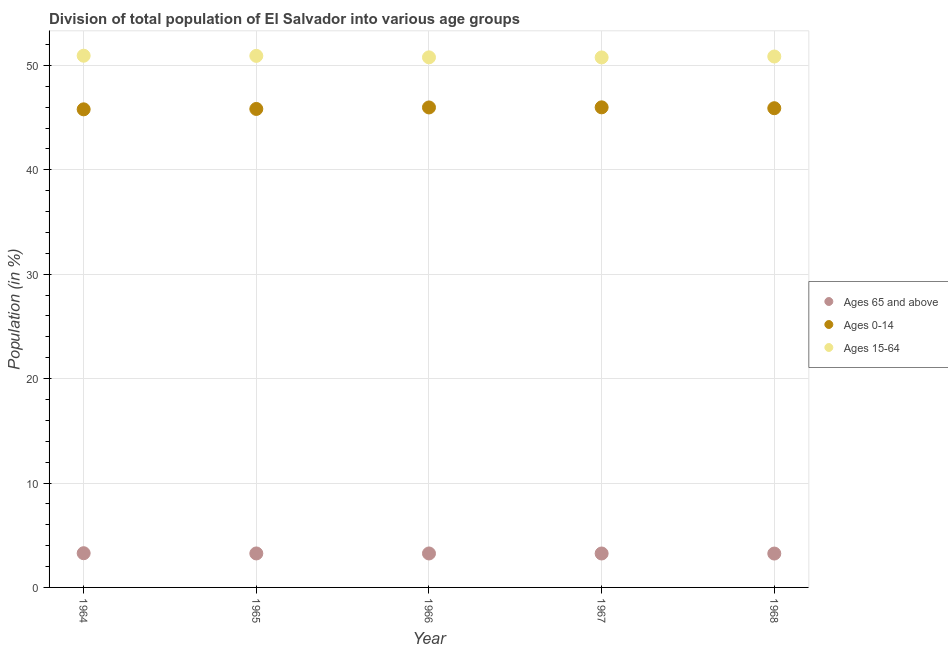Is the number of dotlines equal to the number of legend labels?
Keep it short and to the point. Yes. What is the percentage of population within the age-group 15-64 in 1964?
Your answer should be very brief. 50.93. Across all years, what is the maximum percentage of population within the age-group 15-64?
Offer a very short reply. 50.93. Across all years, what is the minimum percentage of population within the age-group of 65 and above?
Offer a very short reply. 3.24. In which year was the percentage of population within the age-group 0-14 maximum?
Your response must be concise. 1967. In which year was the percentage of population within the age-group 0-14 minimum?
Your answer should be very brief. 1964. What is the total percentage of population within the age-group 15-64 in the graph?
Your answer should be very brief. 254.23. What is the difference between the percentage of population within the age-group 15-64 in 1965 and that in 1968?
Give a very brief answer. 0.06. What is the difference between the percentage of population within the age-group 0-14 in 1966 and the percentage of population within the age-group of 65 and above in 1964?
Keep it short and to the point. 42.7. What is the average percentage of population within the age-group 0-14 per year?
Ensure brevity in your answer.  45.9. In the year 1965, what is the difference between the percentage of population within the age-group of 65 and above and percentage of population within the age-group 0-14?
Make the answer very short. -42.57. What is the ratio of the percentage of population within the age-group 0-14 in 1964 to that in 1967?
Your response must be concise. 1. What is the difference between the highest and the second highest percentage of population within the age-group of 65 and above?
Offer a terse response. 0.02. What is the difference between the highest and the lowest percentage of population within the age-group 0-14?
Keep it short and to the point. 0.19. In how many years, is the percentage of population within the age-group 15-64 greater than the average percentage of population within the age-group 15-64 taken over all years?
Offer a very short reply. 3. Is it the case that in every year, the sum of the percentage of population within the age-group of 65 and above and percentage of population within the age-group 0-14 is greater than the percentage of population within the age-group 15-64?
Provide a succinct answer. No. Is the percentage of population within the age-group 0-14 strictly greater than the percentage of population within the age-group of 65 and above over the years?
Give a very brief answer. Yes. Is the percentage of population within the age-group 15-64 strictly less than the percentage of population within the age-group 0-14 over the years?
Keep it short and to the point. No. How many dotlines are there?
Offer a terse response. 3. How many years are there in the graph?
Offer a very short reply. 5. What is the difference between two consecutive major ticks on the Y-axis?
Keep it short and to the point. 10. Are the values on the major ticks of Y-axis written in scientific E-notation?
Provide a succinct answer. No. How many legend labels are there?
Provide a succinct answer. 3. What is the title of the graph?
Give a very brief answer. Division of total population of El Salvador into various age groups
. Does "Services" appear as one of the legend labels in the graph?
Give a very brief answer. No. What is the Population (in %) in Ages 65 and above in 1964?
Offer a very short reply. 3.28. What is the Population (in %) in Ages 0-14 in 1964?
Your response must be concise. 45.79. What is the Population (in %) in Ages 15-64 in 1964?
Offer a very short reply. 50.93. What is the Population (in %) of Ages 65 and above in 1965?
Give a very brief answer. 3.26. What is the Population (in %) of Ages 0-14 in 1965?
Offer a terse response. 45.83. What is the Population (in %) in Ages 15-64 in 1965?
Ensure brevity in your answer.  50.91. What is the Population (in %) of Ages 65 and above in 1966?
Provide a succinct answer. 3.25. What is the Population (in %) of Ages 0-14 in 1966?
Your answer should be compact. 45.97. What is the Population (in %) of Ages 15-64 in 1966?
Your answer should be compact. 50.77. What is the Population (in %) of Ages 65 and above in 1967?
Offer a terse response. 3.25. What is the Population (in %) in Ages 0-14 in 1967?
Offer a terse response. 45.98. What is the Population (in %) in Ages 15-64 in 1967?
Provide a succinct answer. 50.76. What is the Population (in %) of Ages 65 and above in 1968?
Provide a succinct answer. 3.24. What is the Population (in %) of Ages 0-14 in 1968?
Offer a very short reply. 45.9. What is the Population (in %) of Ages 15-64 in 1968?
Your answer should be compact. 50.85. Across all years, what is the maximum Population (in %) in Ages 65 and above?
Make the answer very short. 3.28. Across all years, what is the maximum Population (in %) of Ages 0-14?
Keep it short and to the point. 45.98. Across all years, what is the maximum Population (in %) in Ages 15-64?
Give a very brief answer. 50.93. Across all years, what is the minimum Population (in %) in Ages 65 and above?
Give a very brief answer. 3.24. Across all years, what is the minimum Population (in %) of Ages 0-14?
Offer a very short reply. 45.79. Across all years, what is the minimum Population (in %) of Ages 15-64?
Ensure brevity in your answer.  50.76. What is the total Population (in %) of Ages 65 and above in the graph?
Offer a terse response. 16.28. What is the total Population (in %) in Ages 0-14 in the graph?
Ensure brevity in your answer.  229.48. What is the total Population (in %) of Ages 15-64 in the graph?
Provide a short and direct response. 254.23. What is the difference between the Population (in %) of Ages 65 and above in 1964 and that in 1965?
Offer a very short reply. 0.02. What is the difference between the Population (in %) in Ages 0-14 in 1964 and that in 1965?
Give a very brief answer. -0.04. What is the difference between the Population (in %) of Ages 15-64 in 1964 and that in 1965?
Ensure brevity in your answer.  0.01. What is the difference between the Population (in %) of Ages 65 and above in 1964 and that in 1966?
Ensure brevity in your answer.  0.02. What is the difference between the Population (in %) in Ages 0-14 in 1964 and that in 1966?
Keep it short and to the point. -0.18. What is the difference between the Population (in %) in Ages 15-64 in 1964 and that in 1966?
Your answer should be compact. 0.16. What is the difference between the Population (in %) in Ages 65 and above in 1964 and that in 1967?
Your answer should be compact. 0.03. What is the difference between the Population (in %) of Ages 0-14 in 1964 and that in 1967?
Provide a short and direct response. -0.19. What is the difference between the Population (in %) in Ages 15-64 in 1964 and that in 1967?
Ensure brevity in your answer.  0.16. What is the difference between the Population (in %) in Ages 65 and above in 1964 and that in 1968?
Give a very brief answer. 0.03. What is the difference between the Population (in %) in Ages 0-14 in 1964 and that in 1968?
Ensure brevity in your answer.  -0.11. What is the difference between the Population (in %) in Ages 15-64 in 1964 and that in 1968?
Offer a very short reply. 0.07. What is the difference between the Population (in %) in Ages 65 and above in 1965 and that in 1966?
Your response must be concise. 0. What is the difference between the Population (in %) of Ages 0-14 in 1965 and that in 1966?
Give a very brief answer. -0.14. What is the difference between the Population (in %) of Ages 15-64 in 1965 and that in 1966?
Provide a short and direct response. 0.14. What is the difference between the Population (in %) in Ages 65 and above in 1965 and that in 1967?
Your answer should be compact. 0.01. What is the difference between the Population (in %) in Ages 0-14 in 1965 and that in 1967?
Ensure brevity in your answer.  -0.15. What is the difference between the Population (in %) in Ages 15-64 in 1965 and that in 1967?
Offer a terse response. 0.15. What is the difference between the Population (in %) of Ages 65 and above in 1965 and that in 1968?
Your answer should be very brief. 0.01. What is the difference between the Population (in %) in Ages 0-14 in 1965 and that in 1968?
Your response must be concise. -0.07. What is the difference between the Population (in %) in Ages 15-64 in 1965 and that in 1968?
Your response must be concise. 0.06. What is the difference between the Population (in %) of Ages 65 and above in 1966 and that in 1967?
Provide a succinct answer. 0. What is the difference between the Population (in %) in Ages 0-14 in 1966 and that in 1967?
Offer a terse response. -0.01. What is the difference between the Population (in %) in Ages 15-64 in 1966 and that in 1967?
Give a very brief answer. 0.01. What is the difference between the Population (in %) in Ages 65 and above in 1966 and that in 1968?
Your response must be concise. 0.01. What is the difference between the Population (in %) in Ages 0-14 in 1966 and that in 1968?
Ensure brevity in your answer.  0.07. What is the difference between the Population (in %) of Ages 15-64 in 1966 and that in 1968?
Offer a terse response. -0.08. What is the difference between the Population (in %) of Ages 65 and above in 1967 and that in 1968?
Offer a very short reply. 0.01. What is the difference between the Population (in %) in Ages 0-14 in 1967 and that in 1968?
Offer a very short reply. 0.08. What is the difference between the Population (in %) of Ages 15-64 in 1967 and that in 1968?
Offer a terse response. -0.09. What is the difference between the Population (in %) of Ages 65 and above in 1964 and the Population (in %) of Ages 0-14 in 1965?
Your answer should be very brief. -42.55. What is the difference between the Population (in %) in Ages 65 and above in 1964 and the Population (in %) in Ages 15-64 in 1965?
Keep it short and to the point. -47.64. What is the difference between the Population (in %) of Ages 0-14 in 1964 and the Population (in %) of Ages 15-64 in 1965?
Provide a short and direct response. -5.12. What is the difference between the Population (in %) of Ages 65 and above in 1964 and the Population (in %) of Ages 0-14 in 1966?
Provide a succinct answer. -42.7. What is the difference between the Population (in %) of Ages 65 and above in 1964 and the Population (in %) of Ages 15-64 in 1966?
Your answer should be compact. -47.49. What is the difference between the Population (in %) of Ages 0-14 in 1964 and the Population (in %) of Ages 15-64 in 1966?
Ensure brevity in your answer.  -4.98. What is the difference between the Population (in %) in Ages 65 and above in 1964 and the Population (in %) in Ages 0-14 in 1967?
Your answer should be very brief. -42.71. What is the difference between the Population (in %) of Ages 65 and above in 1964 and the Population (in %) of Ages 15-64 in 1967?
Ensure brevity in your answer.  -47.49. What is the difference between the Population (in %) of Ages 0-14 in 1964 and the Population (in %) of Ages 15-64 in 1967?
Ensure brevity in your answer.  -4.97. What is the difference between the Population (in %) in Ages 65 and above in 1964 and the Population (in %) in Ages 0-14 in 1968?
Your answer should be very brief. -42.62. What is the difference between the Population (in %) of Ages 65 and above in 1964 and the Population (in %) of Ages 15-64 in 1968?
Your response must be concise. -47.58. What is the difference between the Population (in %) in Ages 0-14 in 1964 and the Population (in %) in Ages 15-64 in 1968?
Your answer should be very brief. -5.06. What is the difference between the Population (in %) of Ages 65 and above in 1965 and the Population (in %) of Ages 0-14 in 1966?
Ensure brevity in your answer.  -42.72. What is the difference between the Population (in %) of Ages 65 and above in 1965 and the Population (in %) of Ages 15-64 in 1966?
Provide a short and direct response. -47.52. What is the difference between the Population (in %) in Ages 0-14 in 1965 and the Population (in %) in Ages 15-64 in 1966?
Your response must be concise. -4.94. What is the difference between the Population (in %) in Ages 65 and above in 1965 and the Population (in %) in Ages 0-14 in 1967?
Make the answer very short. -42.73. What is the difference between the Population (in %) in Ages 65 and above in 1965 and the Population (in %) in Ages 15-64 in 1967?
Make the answer very short. -47.51. What is the difference between the Population (in %) in Ages 0-14 in 1965 and the Population (in %) in Ages 15-64 in 1967?
Offer a terse response. -4.93. What is the difference between the Population (in %) in Ages 65 and above in 1965 and the Population (in %) in Ages 0-14 in 1968?
Give a very brief answer. -42.65. What is the difference between the Population (in %) of Ages 65 and above in 1965 and the Population (in %) of Ages 15-64 in 1968?
Provide a short and direct response. -47.6. What is the difference between the Population (in %) in Ages 0-14 in 1965 and the Population (in %) in Ages 15-64 in 1968?
Keep it short and to the point. -5.02. What is the difference between the Population (in %) of Ages 65 and above in 1966 and the Population (in %) of Ages 0-14 in 1967?
Provide a short and direct response. -42.73. What is the difference between the Population (in %) in Ages 65 and above in 1966 and the Population (in %) in Ages 15-64 in 1967?
Ensure brevity in your answer.  -47.51. What is the difference between the Population (in %) of Ages 0-14 in 1966 and the Population (in %) of Ages 15-64 in 1967?
Ensure brevity in your answer.  -4.79. What is the difference between the Population (in %) in Ages 65 and above in 1966 and the Population (in %) in Ages 0-14 in 1968?
Keep it short and to the point. -42.65. What is the difference between the Population (in %) of Ages 65 and above in 1966 and the Population (in %) of Ages 15-64 in 1968?
Provide a short and direct response. -47.6. What is the difference between the Population (in %) in Ages 0-14 in 1966 and the Population (in %) in Ages 15-64 in 1968?
Keep it short and to the point. -4.88. What is the difference between the Population (in %) in Ages 65 and above in 1967 and the Population (in %) in Ages 0-14 in 1968?
Keep it short and to the point. -42.65. What is the difference between the Population (in %) of Ages 65 and above in 1967 and the Population (in %) of Ages 15-64 in 1968?
Give a very brief answer. -47.6. What is the difference between the Population (in %) in Ages 0-14 in 1967 and the Population (in %) in Ages 15-64 in 1968?
Give a very brief answer. -4.87. What is the average Population (in %) of Ages 65 and above per year?
Your answer should be very brief. 3.26. What is the average Population (in %) of Ages 0-14 per year?
Your answer should be compact. 45.9. What is the average Population (in %) in Ages 15-64 per year?
Offer a very short reply. 50.85. In the year 1964, what is the difference between the Population (in %) in Ages 65 and above and Population (in %) in Ages 0-14?
Keep it short and to the point. -42.52. In the year 1964, what is the difference between the Population (in %) of Ages 65 and above and Population (in %) of Ages 15-64?
Your answer should be compact. -47.65. In the year 1964, what is the difference between the Population (in %) in Ages 0-14 and Population (in %) in Ages 15-64?
Your answer should be compact. -5.14. In the year 1965, what is the difference between the Population (in %) in Ages 65 and above and Population (in %) in Ages 0-14?
Your answer should be compact. -42.57. In the year 1965, what is the difference between the Population (in %) of Ages 65 and above and Population (in %) of Ages 15-64?
Give a very brief answer. -47.66. In the year 1965, what is the difference between the Population (in %) of Ages 0-14 and Population (in %) of Ages 15-64?
Provide a succinct answer. -5.08. In the year 1966, what is the difference between the Population (in %) of Ages 65 and above and Population (in %) of Ages 0-14?
Offer a terse response. -42.72. In the year 1966, what is the difference between the Population (in %) in Ages 65 and above and Population (in %) in Ages 15-64?
Your response must be concise. -47.52. In the year 1966, what is the difference between the Population (in %) in Ages 0-14 and Population (in %) in Ages 15-64?
Provide a short and direct response. -4.8. In the year 1967, what is the difference between the Population (in %) in Ages 65 and above and Population (in %) in Ages 0-14?
Your response must be concise. -42.73. In the year 1967, what is the difference between the Population (in %) in Ages 65 and above and Population (in %) in Ages 15-64?
Offer a terse response. -47.51. In the year 1967, what is the difference between the Population (in %) of Ages 0-14 and Population (in %) of Ages 15-64?
Make the answer very short. -4.78. In the year 1968, what is the difference between the Population (in %) of Ages 65 and above and Population (in %) of Ages 0-14?
Your answer should be very brief. -42.66. In the year 1968, what is the difference between the Population (in %) in Ages 65 and above and Population (in %) in Ages 15-64?
Make the answer very short. -47.61. In the year 1968, what is the difference between the Population (in %) in Ages 0-14 and Population (in %) in Ages 15-64?
Offer a terse response. -4.95. What is the ratio of the Population (in %) of Ages 65 and above in 1964 to that in 1965?
Provide a short and direct response. 1.01. What is the ratio of the Population (in %) of Ages 65 and above in 1964 to that in 1966?
Keep it short and to the point. 1.01. What is the ratio of the Population (in %) of Ages 0-14 in 1964 to that in 1966?
Your answer should be very brief. 1. What is the ratio of the Population (in %) of Ages 15-64 in 1964 to that in 1966?
Make the answer very short. 1. What is the ratio of the Population (in %) in Ages 65 and above in 1964 to that in 1967?
Offer a terse response. 1.01. What is the ratio of the Population (in %) in Ages 65 and above in 1964 to that in 1968?
Give a very brief answer. 1.01. What is the ratio of the Population (in %) of Ages 15-64 in 1964 to that in 1968?
Provide a short and direct response. 1. What is the ratio of the Population (in %) of Ages 15-64 in 1965 to that in 1966?
Your answer should be very brief. 1. What is the ratio of the Population (in %) of Ages 0-14 in 1965 to that in 1967?
Ensure brevity in your answer.  1. What is the ratio of the Population (in %) of Ages 15-64 in 1965 to that in 1967?
Make the answer very short. 1. What is the ratio of the Population (in %) of Ages 0-14 in 1965 to that in 1968?
Offer a very short reply. 1. What is the ratio of the Population (in %) in Ages 15-64 in 1965 to that in 1968?
Ensure brevity in your answer.  1. What is the ratio of the Population (in %) in Ages 0-14 in 1966 to that in 1967?
Offer a terse response. 1. What is the ratio of the Population (in %) in Ages 15-64 in 1966 to that in 1967?
Keep it short and to the point. 1. What is the ratio of the Population (in %) of Ages 65 and above in 1966 to that in 1968?
Give a very brief answer. 1. What is the ratio of the Population (in %) of Ages 0-14 in 1966 to that in 1968?
Keep it short and to the point. 1. What is the ratio of the Population (in %) of Ages 15-64 in 1966 to that in 1968?
Your answer should be very brief. 1. What is the ratio of the Population (in %) in Ages 65 and above in 1967 to that in 1968?
Provide a short and direct response. 1. What is the difference between the highest and the second highest Population (in %) in Ages 65 and above?
Make the answer very short. 0.02. What is the difference between the highest and the second highest Population (in %) in Ages 0-14?
Make the answer very short. 0.01. What is the difference between the highest and the second highest Population (in %) in Ages 15-64?
Provide a succinct answer. 0.01. What is the difference between the highest and the lowest Population (in %) in Ages 65 and above?
Provide a succinct answer. 0.03. What is the difference between the highest and the lowest Population (in %) of Ages 0-14?
Ensure brevity in your answer.  0.19. What is the difference between the highest and the lowest Population (in %) of Ages 15-64?
Your response must be concise. 0.16. 